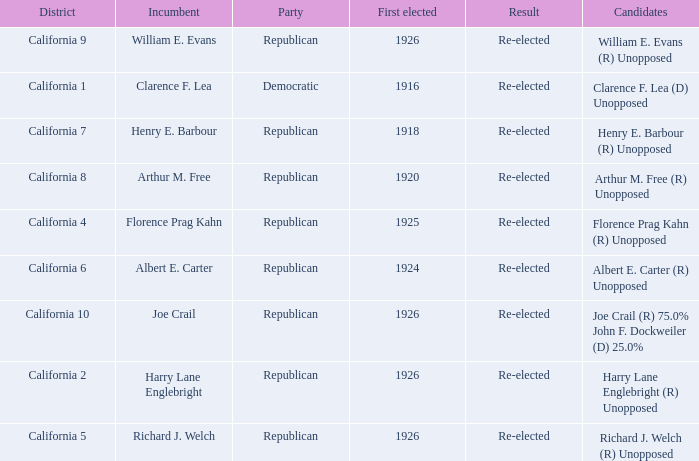What's the political gathering with current holder being william e. evans? Republican. 